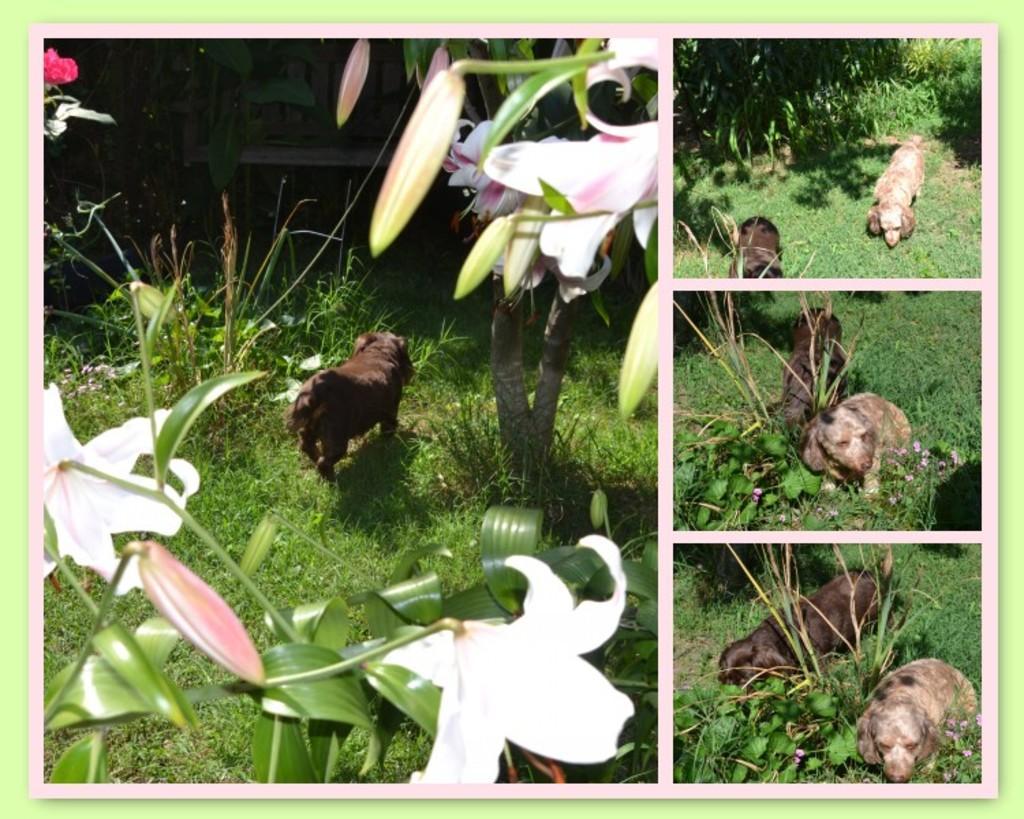How would you summarize this image in a sentence or two? I see this is a collage image and I see 2 dogs which are of brown and cream in color and I see the green grass and I see plants on which there are flowers which are of white and pink in color and I see the buds. 